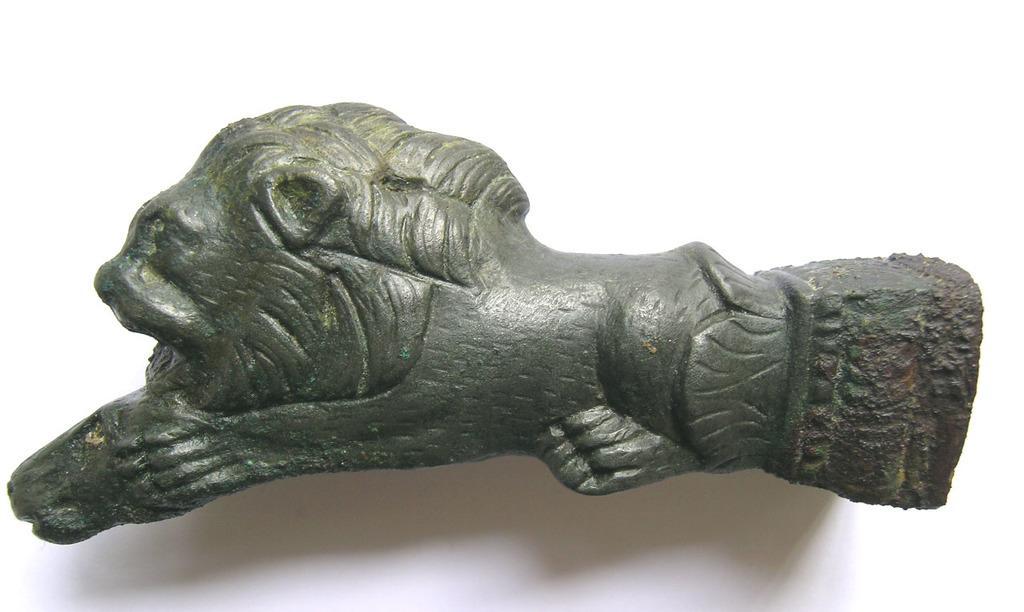Can you describe this image briefly? In this image, I can see a sculpture. There is a white background. 